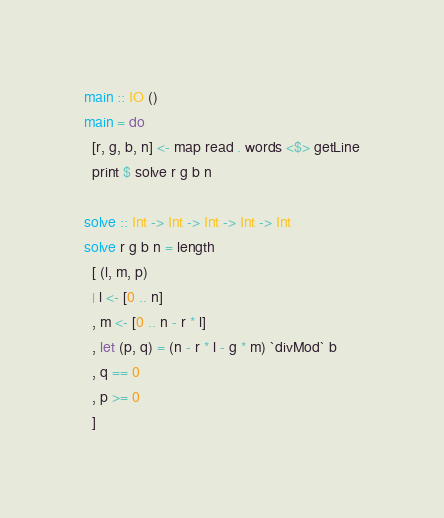<code> <loc_0><loc_0><loc_500><loc_500><_Haskell_>main :: IO ()
main = do
  [r, g, b, n] <- map read . words <$> getLine
  print $ solve r g b n

solve :: Int -> Int -> Int -> Int -> Int
solve r g b n = length
  [ (l, m, p)
  | l <- [0 .. n]
  , m <- [0 .. n - r * l]
  , let (p, q) = (n - r * l - g * m) `divMod` b
  , q == 0
  , p >= 0
  ]
</code> 